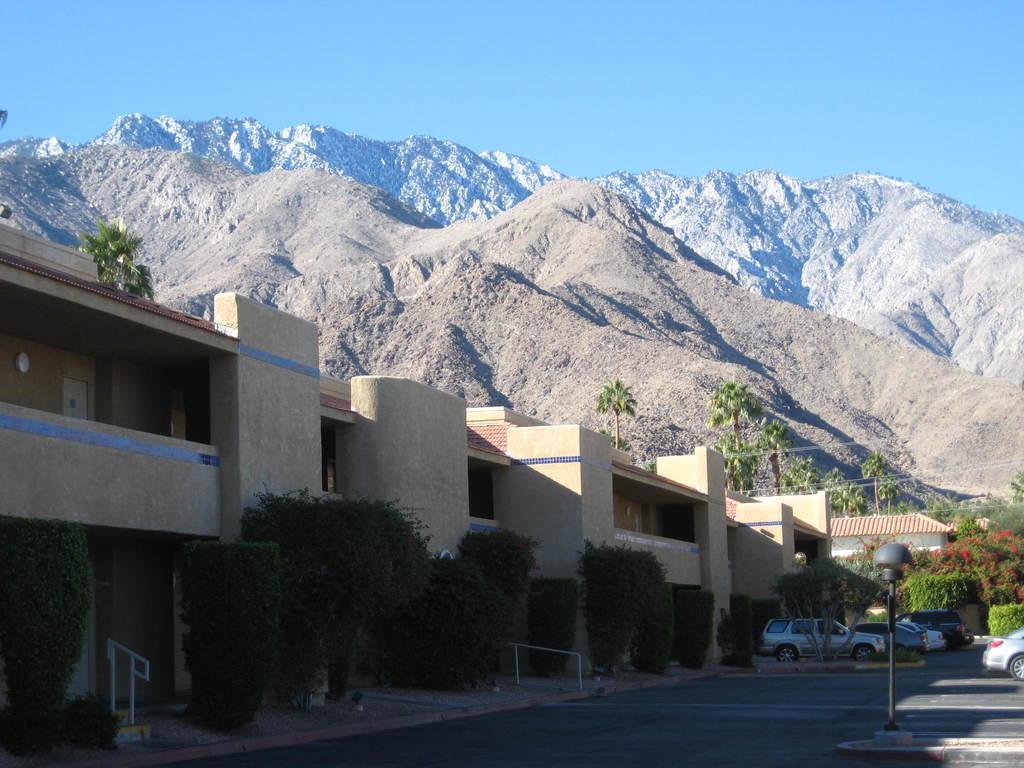In one or two sentences, can you explain what this image depicts? In this image there is the sky truncated towards the top of the image, there are mountains truncated, there are trees, there are trees truncated towards the right of the image, there are plants, there is a plant truncated towards the left of the image, there are buildings, there is a building truncated towards the left of the image, there is road truncated towards the bottom of the image, there is pole, there are vehicles on the road, there is a vehicle truncated towards the right of the image. 